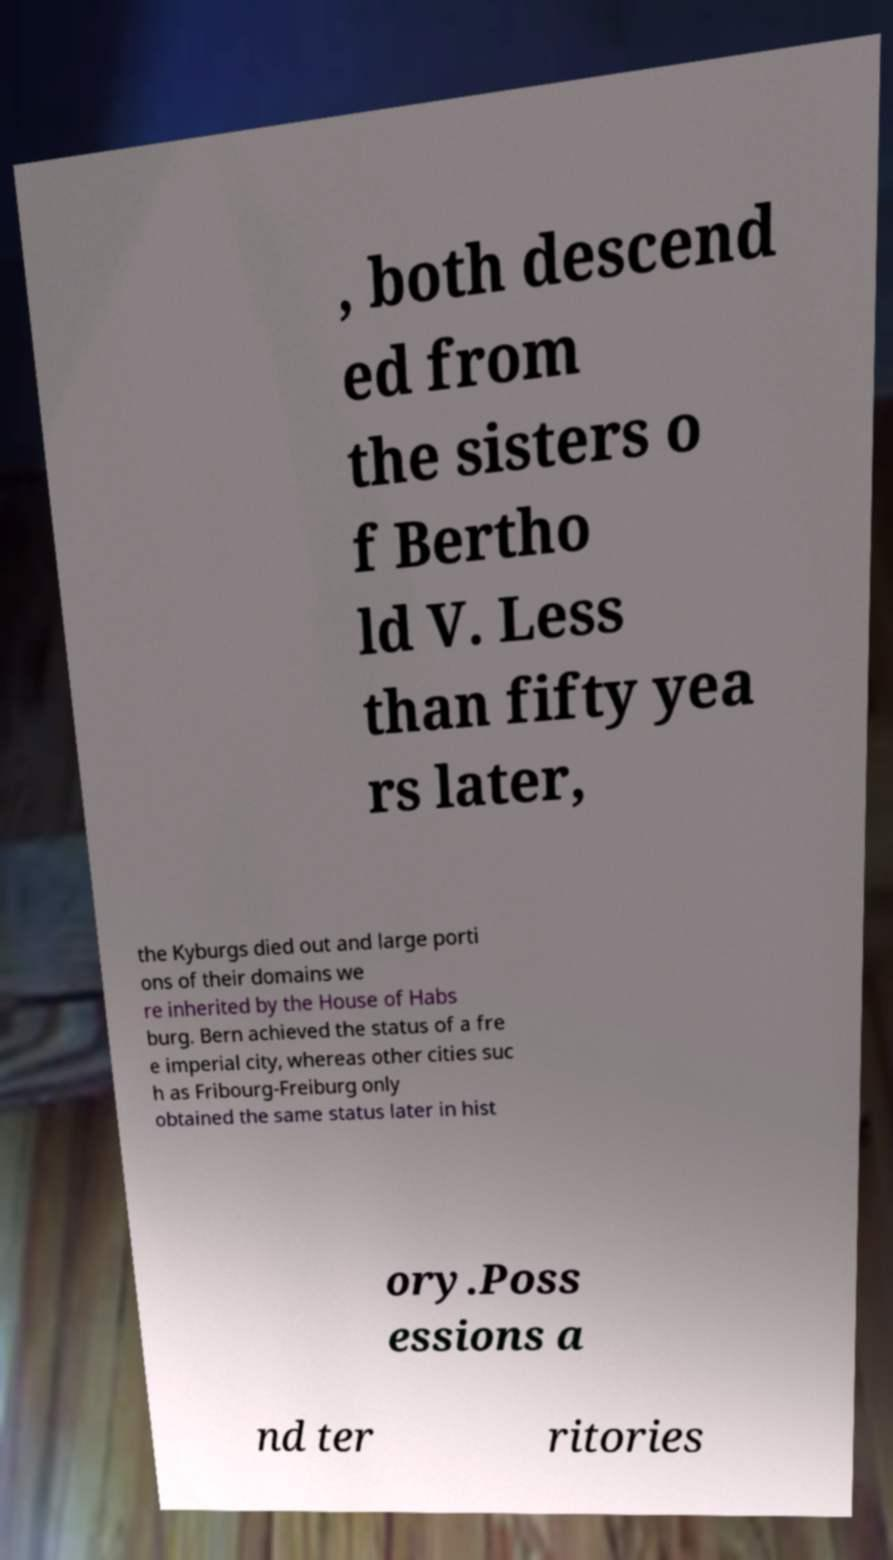Could you extract and type out the text from this image? , both descend ed from the sisters o f Bertho ld V. Less than fifty yea rs later, the Kyburgs died out and large porti ons of their domains we re inherited by the House of Habs burg. Bern achieved the status of a fre e imperial city, whereas other cities suc h as Fribourg-Freiburg only obtained the same status later in hist ory.Poss essions a nd ter ritories 